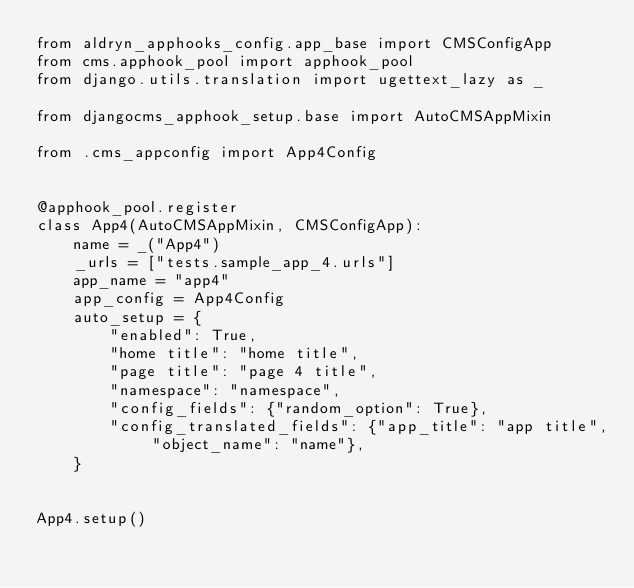Convert code to text. <code><loc_0><loc_0><loc_500><loc_500><_Python_>from aldryn_apphooks_config.app_base import CMSConfigApp
from cms.apphook_pool import apphook_pool
from django.utils.translation import ugettext_lazy as _

from djangocms_apphook_setup.base import AutoCMSAppMixin

from .cms_appconfig import App4Config


@apphook_pool.register
class App4(AutoCMSAppMixin, CMSConfigApp):
    name = _("App4")
    _urls = ["tests.sample_app_4.urls"]
    app_name = "app4"
    app_config = App4Config
    auto_setup = {
        "enabled": True,
        "home title": "home title",
        "page title": "page 4 title",
        "namespace": "namespace",
        "config_fields": {"random_option": True},
        "config_translated_fields": {"app_title": "app title", "object_name": "name"},
    }


App4.setup()
</code> 